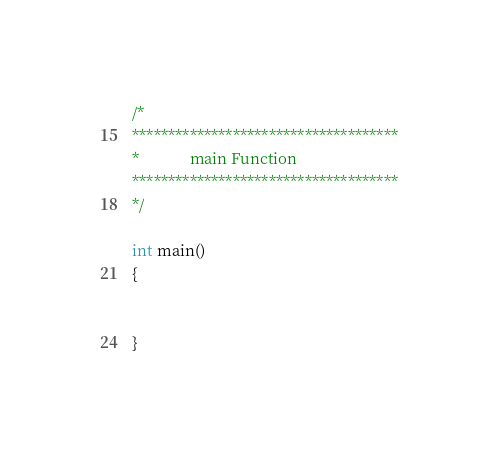<code> <loc_0><loc_0><loc_500><loc_500><_C_>/*
*************************************
*             main Function
*************************************
*/

int main()
{


}</code> 